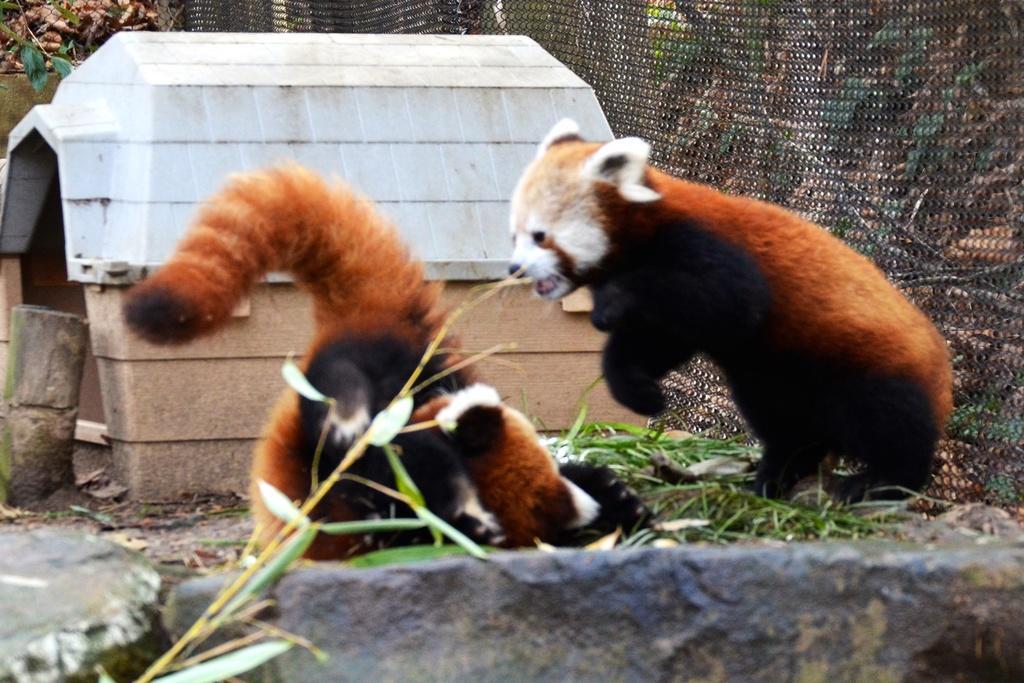Please provide a concise description of this image. In this image we can see the red pandas on the ground. We can also see some grass, a shed, a wooden log, some plants and the mesh. On the bottom of the image we can see a plant and the rocks. 